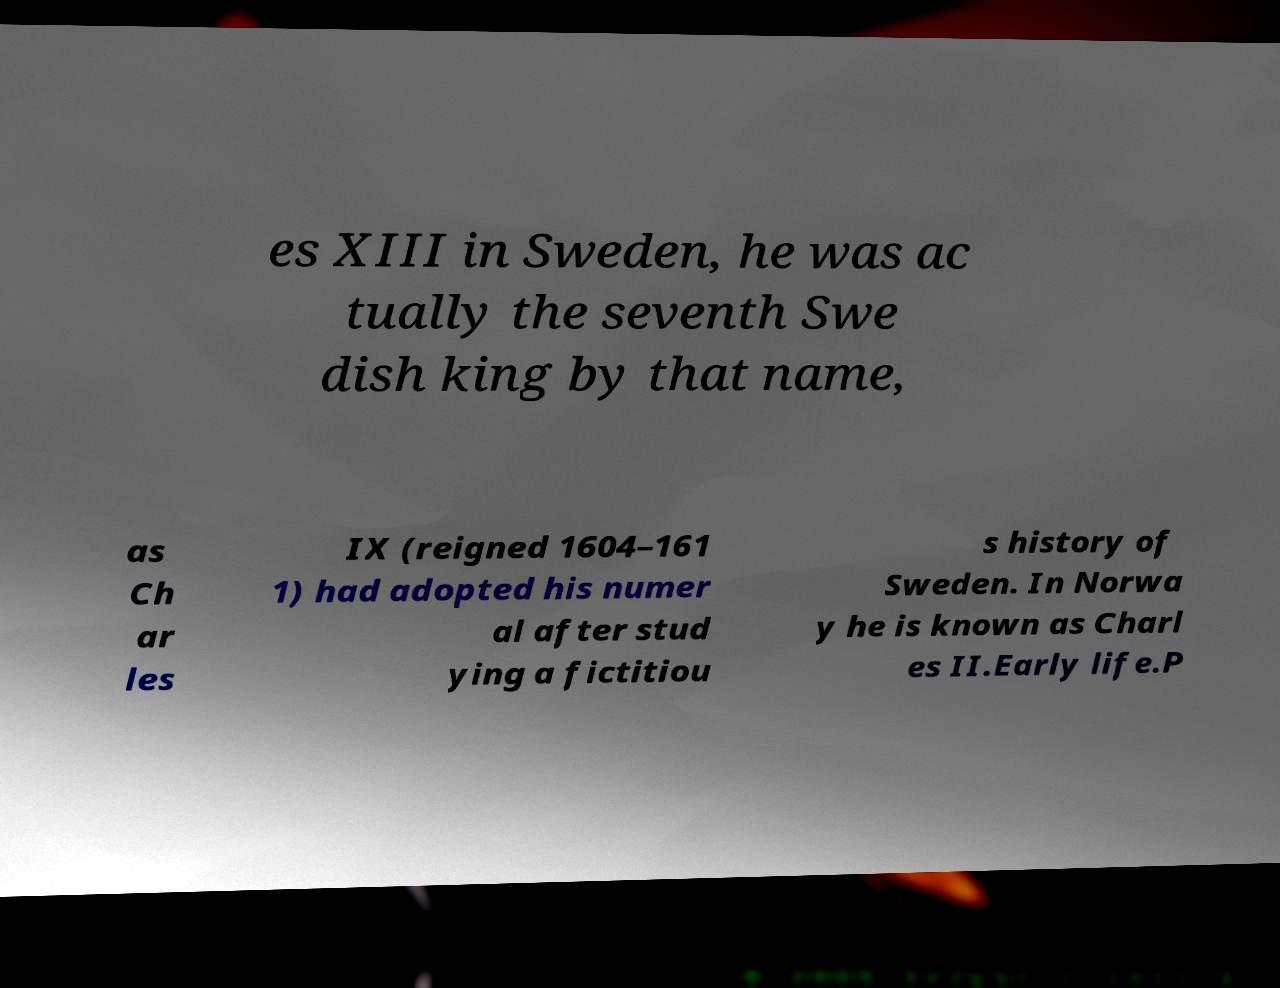For documentation purposes, I need the text within this image transcribed. Could you provide that? es XIII in Sweden, he was ac tually the seventh Swe dish king by that name, as Ch ar les IX (reigned 1604–161 1) had adopted his numer al after stud ying a fictitiou s history of Sweden. In Norwa y he is known as Charl es II.Early life.P 